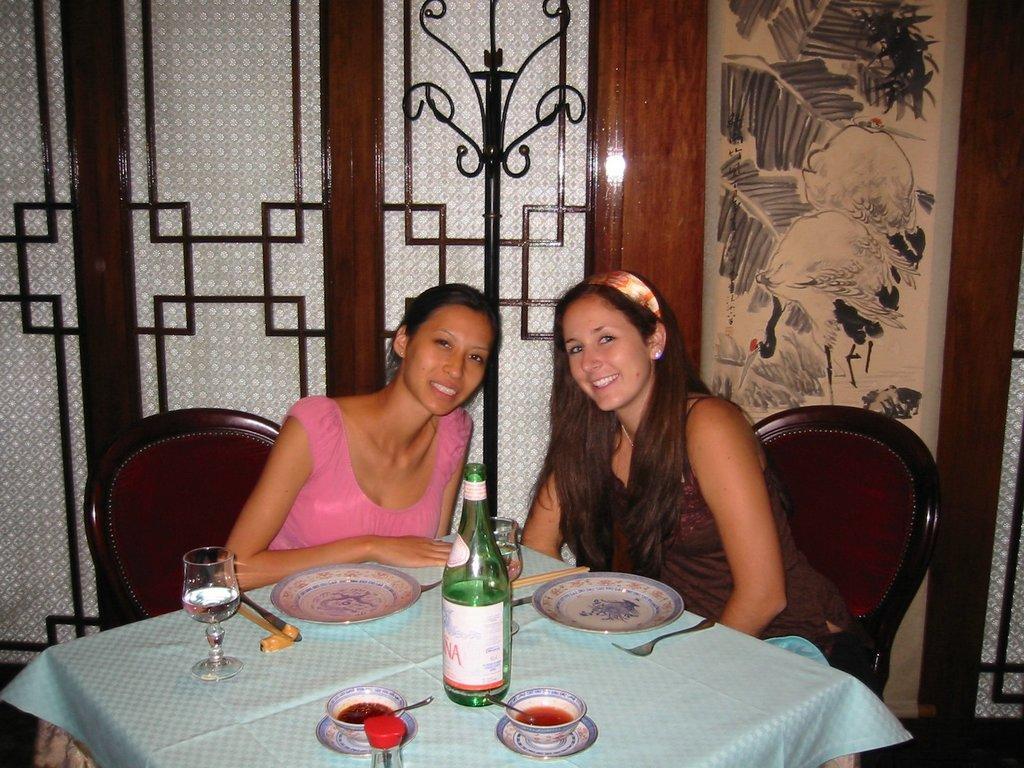Could you give a brief overview of what you see in this image? In this picture, two women one in pink t-shirt and the other in black t-shirt are sitting on chair in front of table. We see glass bottle, bowl, spoon, plate and glass, on which, are placed on the table. Behind them, we see glass doors and beside that, we see a door which is in white and brown color. 